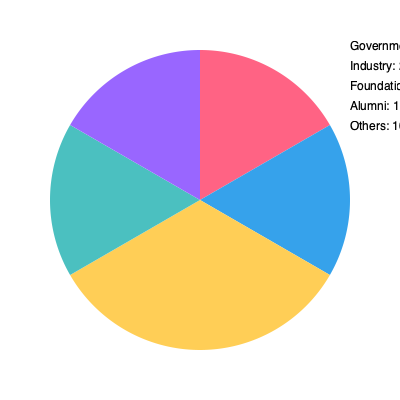Based on the pie chart showing DMU's research funding sources, which sector contributes the largest percentage to the university's research budget? To determine the largest contributor to DMU's research funding, we need to compare the percentages for each sector:

1. Government: 30%
2. Industry: 25%
3. Foundations: 20%
4. Alumni: 15%
5. Others: 10%

By comparing these percentages, we can see that the Government sector has the highest percentage at 30%. This makes it the largest contributor to DMU's research funding.

It's worth noting that this chart shows a significant diversification of funding sources, which is a common strategy for universities to ensure stability in research funding. The fact that government funding is the largest source is typical for many universities, as public funding often plays a crucial role in supporting academic research.
Answer: Government 